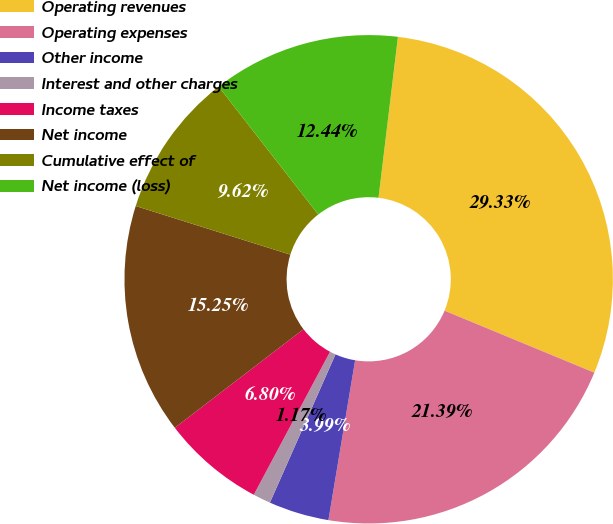Convert chart to OTSL. <chart><loc_0><loc_0><loc_500><loc_500><pie_chart><fcel>Operating revenues<fcel>Operating expenses<fcel>Other income<fcel>Interest and other charges<fcel>Income taxes<fcel>Net income<fcel>Cumulative effect of<fcel>Net income (loss)<nl><fcel>29.33%<fcel>21.39%<fcel>3.99%<fcel>1.17%<fcel>6.8%<fcel>15.25%<fcel>9.62%<fcel>12.44%<nl></chart> 